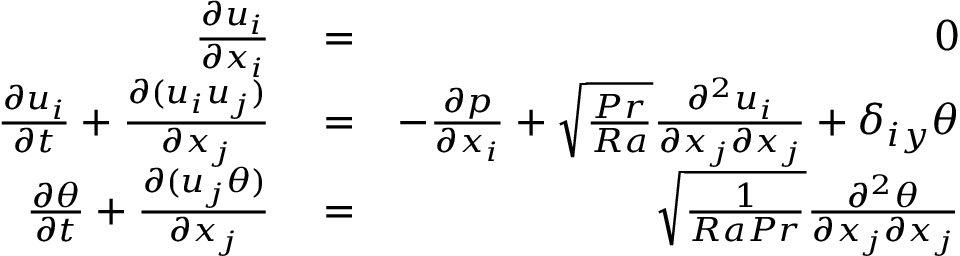<formula> <loc_0><loc_0><loc_500><loc_500>\begin{array} { r l r } { \frac { \partial u _ { i } } { \partial x _ { i } } } & = } & { 0 } \\ { \frac { \partial u _ { i } } { \partial t } + \frac { \partial ( u _ { i } u _ { j } ) } { \partial x _ { j } } } & = } & { - \frac { \partial p } { \partial x _ { i } } + \sqrt { \frac { P r } { R a } } \frac { \partial ^ { 2 } u _ { i } } { \partial x _ { j } \partial x _ { j } } + \delta _ { i y } \theta } \\ { \frac { \partial \theta } { \partial t } + \frac { \partial ( u _ { j } \theta ) } { \partial x _ { j } } } & = } & { \sqrt { \frac { 1 } { R a P r } } \frac { \partial ^ { 2 } \theta } { \partial x _ { j } \partial x _ { j } } } \end{array}</formula> 